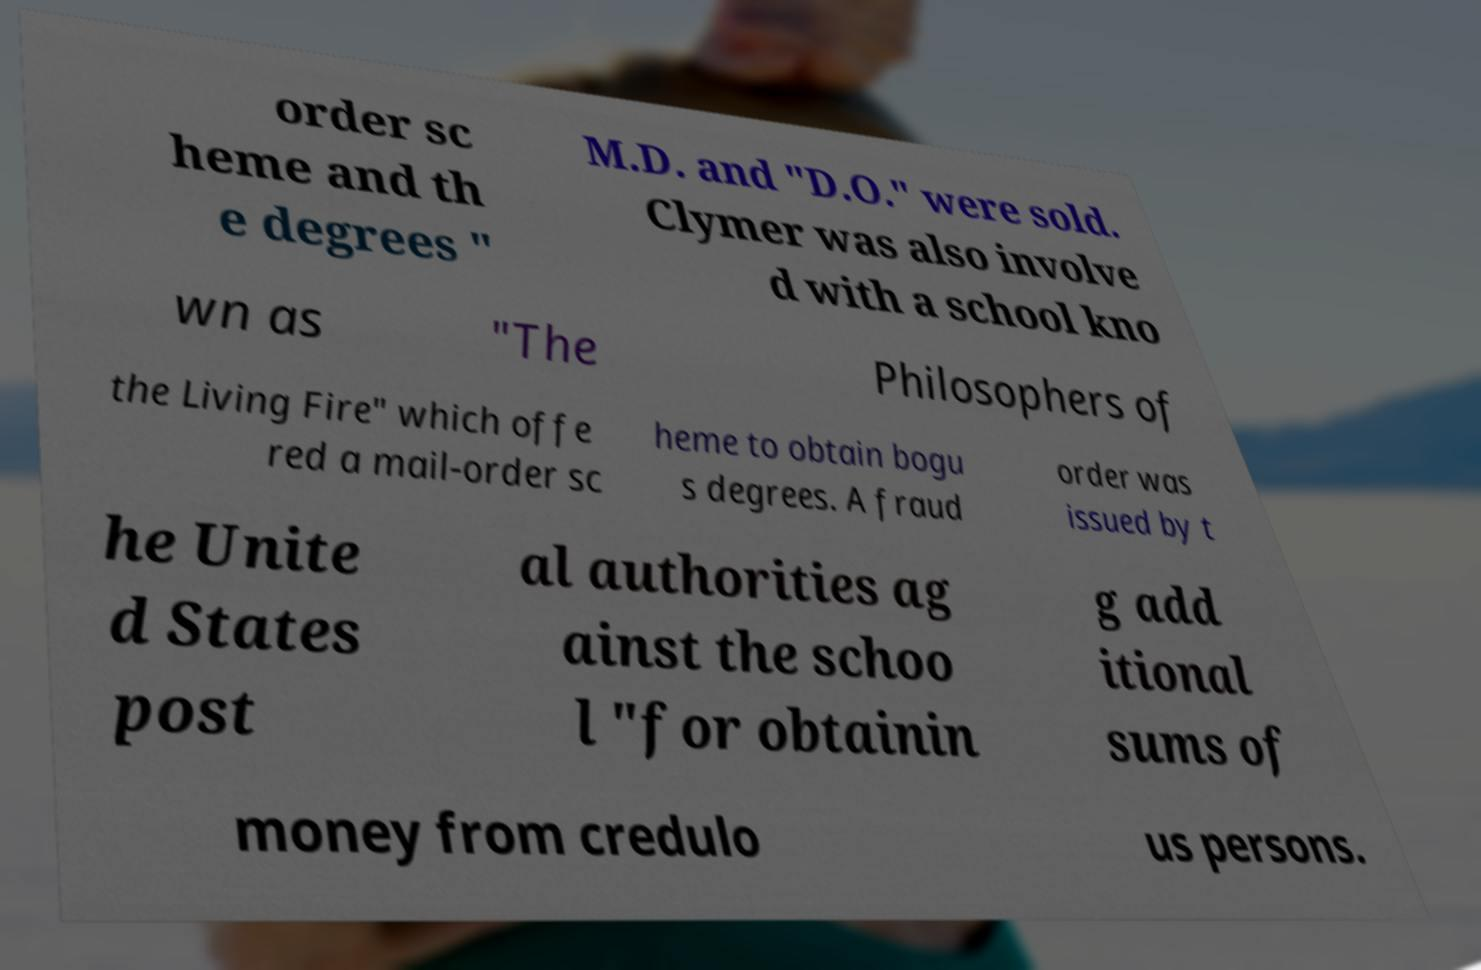What messages or text are displayed in this image? I need them in a readable, typed format. order sc heme and th e degrees " M.D. and "D.O." were sold. Clymer was also involve d with a school kno wn as "The Philosophers of the Living Fire" which offe red a mail-order sc heme to obtain bogu s degrees. A fraud order was issued by t he Unite d States post al authorities ag ainst the schoo l "for obtainin g add itional sums of money from credulo us persons. 